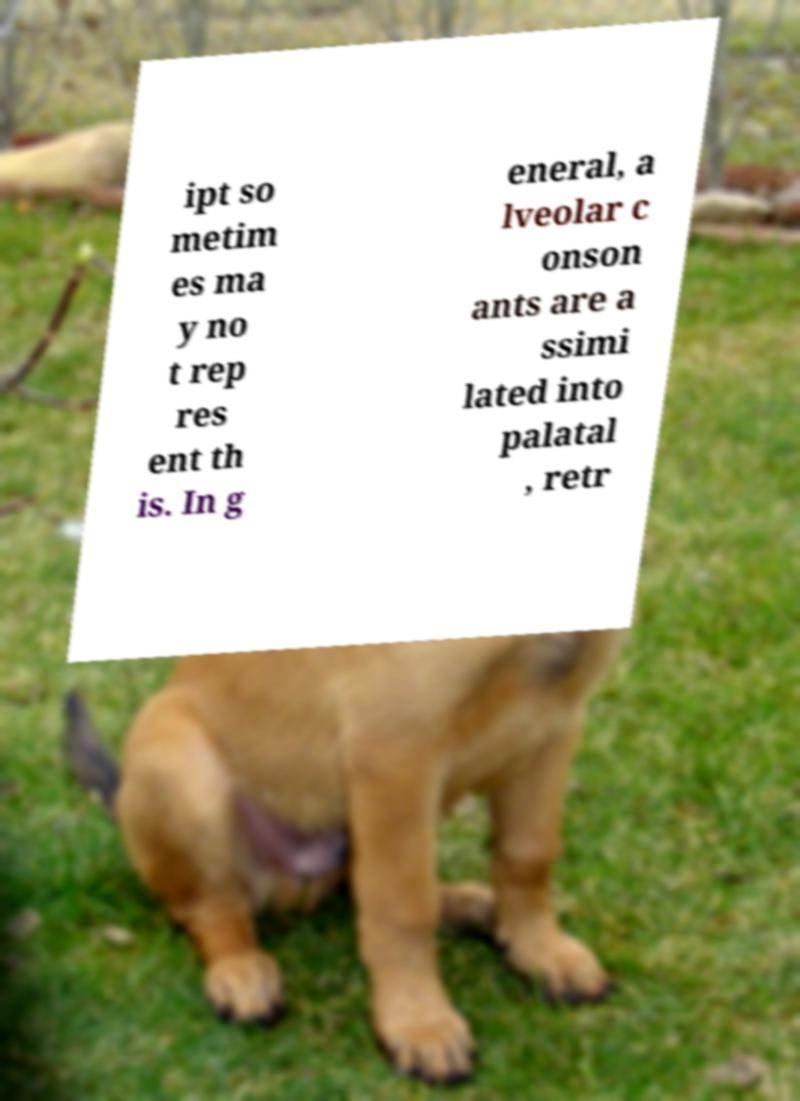For documentation purposes, I need the text within this image transcribed. Could you provide that? ipt so metim es ma y no t rep res ent th is. In g eneral, a lveolar c onson ants are a ssimi lated into palatal , retr 